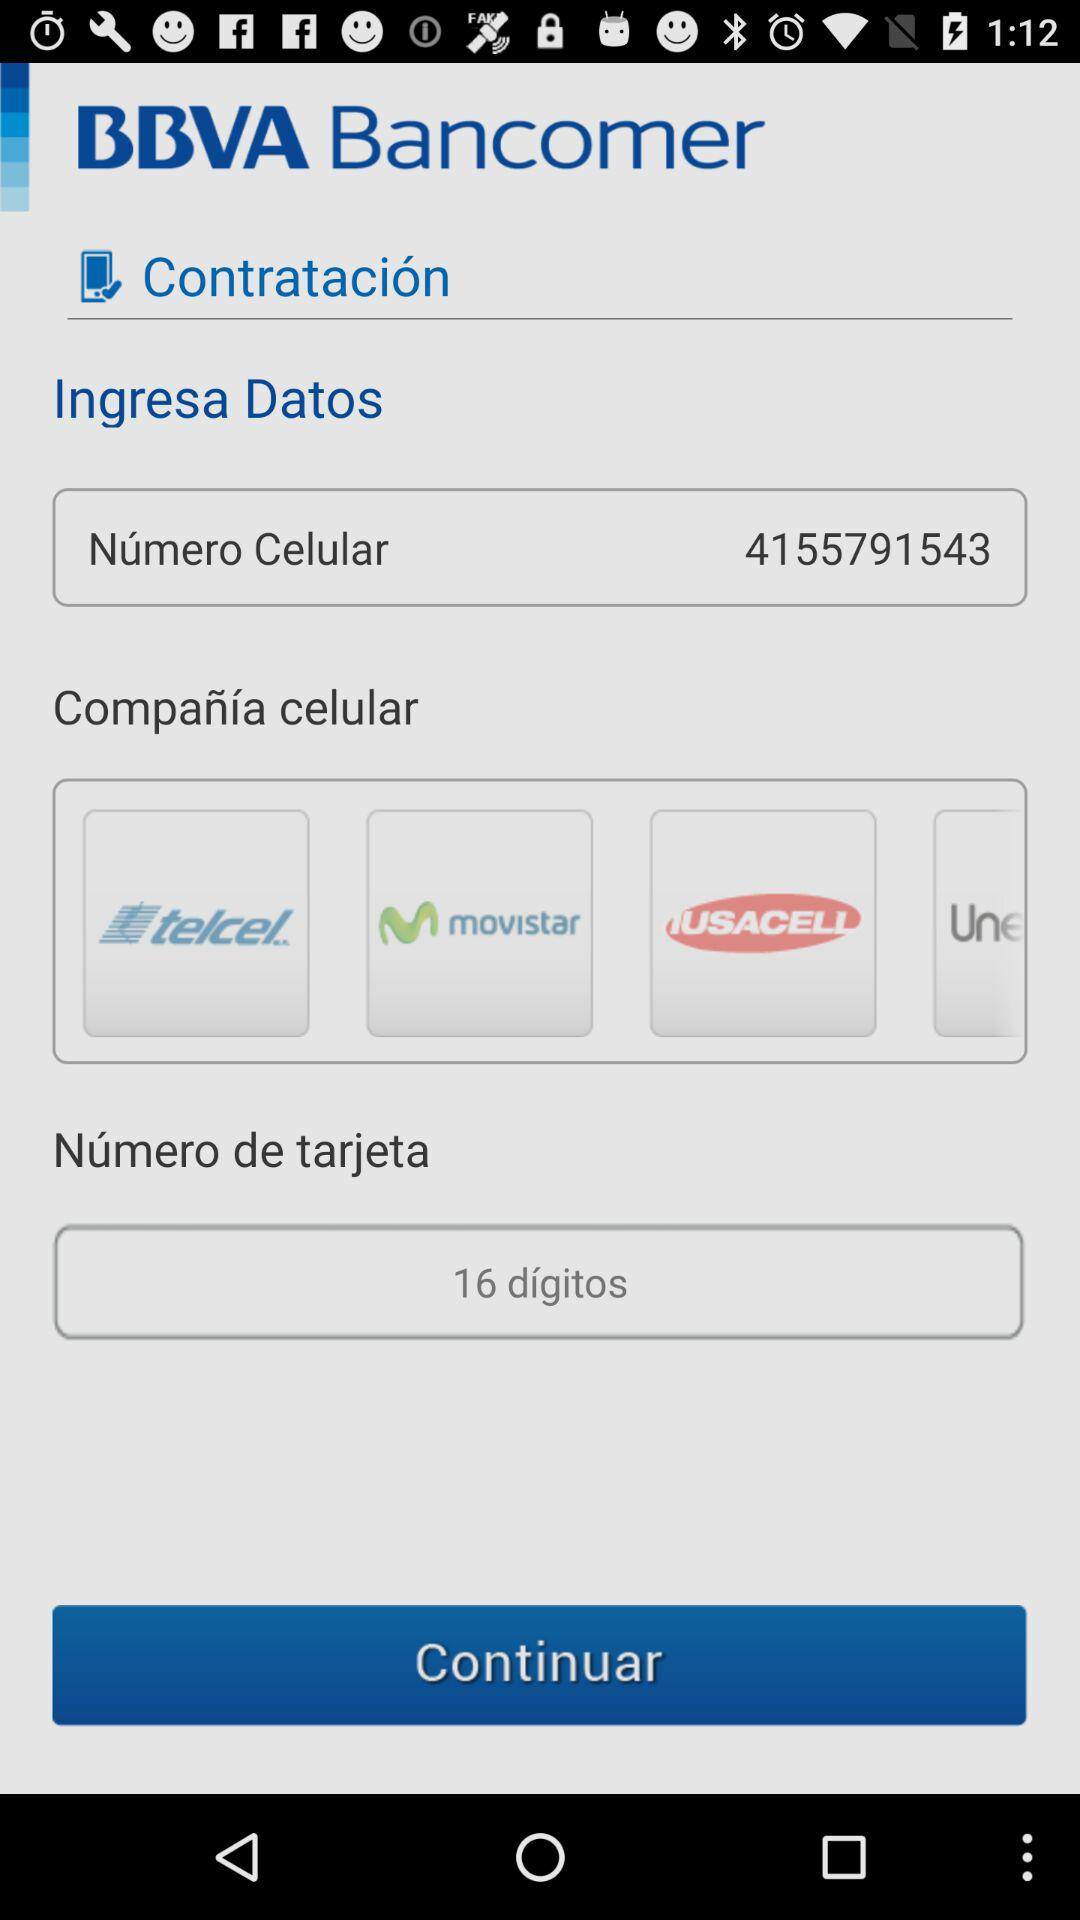How many digits are there in the phone number?
Answer the question using a single word or phrase. 10 